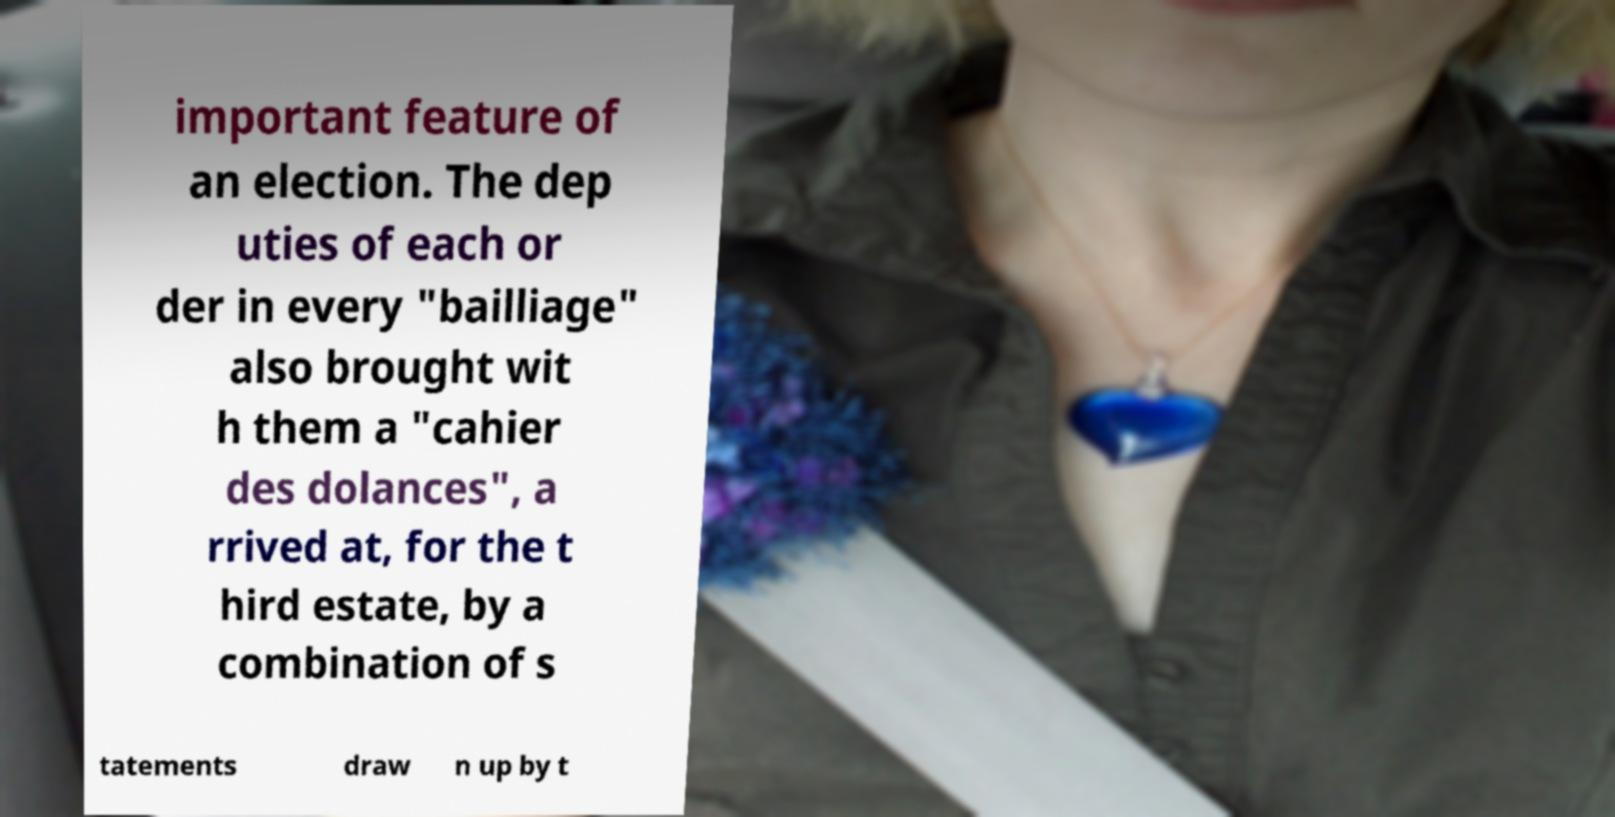Could you extract and type out the text from this image? important feature of an election. The dep uties of each or der in every "bailliage" also brought wit h them a "cahier des dolances", a rrived at, for the t hird estate, by a combination of s tatements draw n up by t 